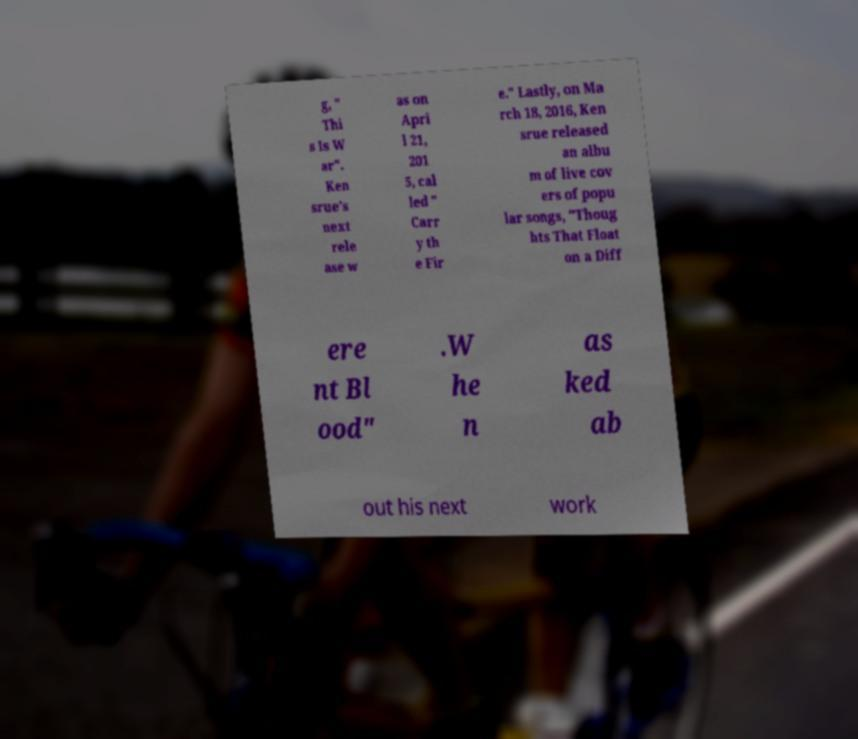Can you accurately transcribe the text from the provided image for me? g, " Thi s Is W ar". Ken srue's next rele ase w as on Apri l 21, 201 5, cal led " Carr y th e Fir e." Lastly, on Ma rch 18, 2016, Ken srue released an albu m of live cov ers of popu lar songs, "Thoug hts That Float on a Diff ere nt Bl ood" .W he n as ked ab out his next work 